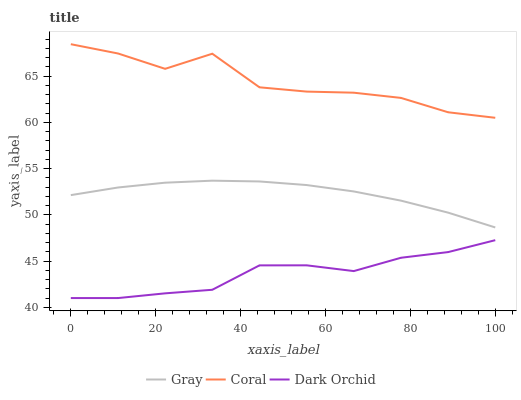Does Dark Orchid have the minimum area under the curve?
Answer yes or no. Yes. Does Coral have the maximum area under the curve?
Answer yes or no. Yes. Does Coral have the minimum area under the curve?
Answer yes or no. No. Does Dark Orchid have the maximum area under the curve?
Answer yes or no. No. Is Gray the smoothest?
Answer yes or no. Yes. Is Coral the roughest?
Answer yes or no. Yes. Is Dark Orchid the smoothest?
Answer yes or no. No. Is Dark Orchid the roughest?
Answer yes or no. No. Does Dark Orchid have the lowest value?
Answer yes or no. Yes. Does Coral have the lowest value?
Answer yes or no. No. Does Coral have the highest value?
Answer yes or no. Yes. Does Dark Orchid have the highest value?
Answer yes or no. No. Is Dark Orchid less than Gray?
Answer yes or no. Yes. Is Gray greater than Dark Orchid?
Answer yes or no. Yes. Does Dark Orchid intersect Gray?
Answer yes or no. No. 